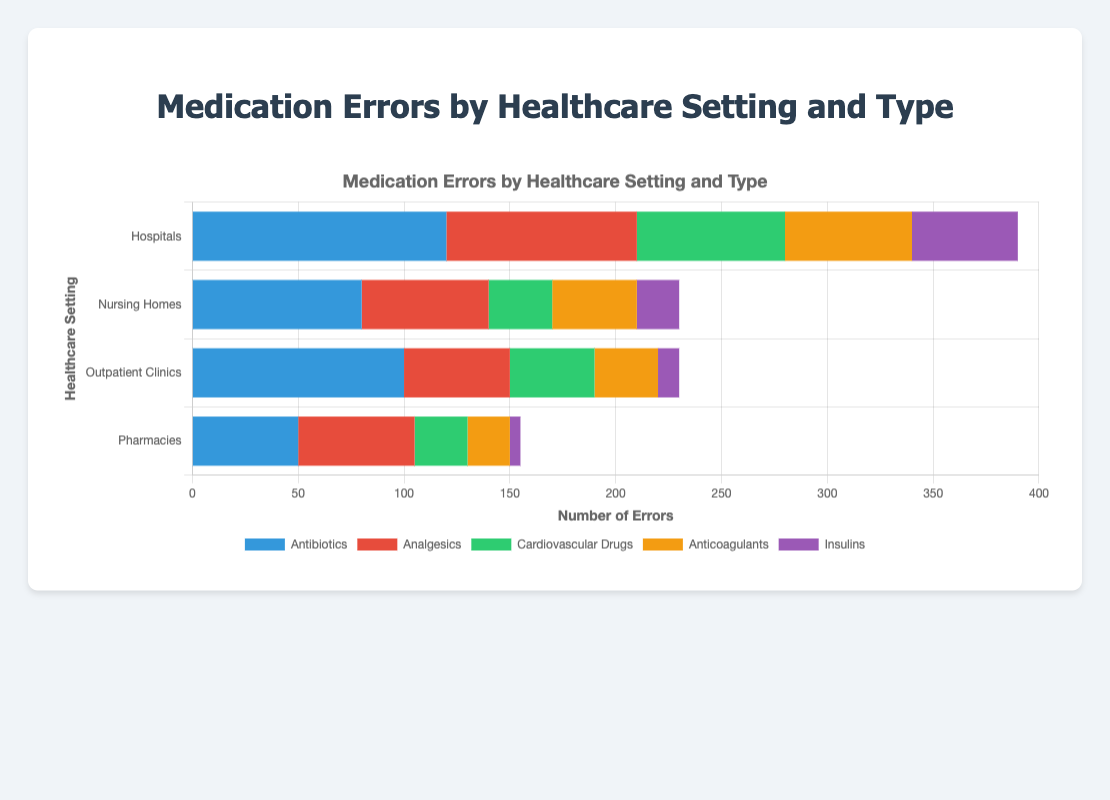Which healthcare setting has the highest number of medication errors in total? To determine the setting with the highest total medication errors, sum the errors for each setting. Hospitals: 120 + 90 + 70 + 60 + 50 = 390, Nursing Homes: 80 + 60 + 30 + 40 + 20 = 230, Outpatient Clinics: 100 + 50 + 40 + 30 + 10 = 230, Pharmacies: 50 + 55 + 25 + 20 + 5 = 155. The hospital has the highest number.
Answer: Hospitals In which healthcare setting are antibiotic errors the most frequent? Look for the longest segment in the bar representing antibiotics across each healthcare setting: Hospitals (120), Nursing Homes (80), Outpatient Clinics (100), Pharmacies (50). The highest value is 120 in Hospitals.
Answer: Hospitals What is the sum of Analgesic errors in Nursing Homes and Pharmacies? Add the number of Analgesic errors in Nursing Homes and Pharmacies. Nursing Homes: 60, Pharmacies: 55. Hence, 60 + 55 = 115.
Answer: 115 Which type of medication has the least errors in Outpatient Clinics? Examine the Outpatient Clinics bar for each medication type: Antibiotics (100), Analgesics (50), Cardiovascular Drugs (40), Anticoagulants (30), Insulins (10). Insulins have the lowest value, 10.
Answer: Insulins How does the number of cardiovascular drug errors in Hospitals compare to those in Nursing Homes? Cardiovascular drug errors in Hospitals are 70, and in Nursing Homes are 30. 70 is greater than 30.
Answer: Greater What is the average number of antibiotic errors across all healthcare settings? Add the number of antibiotic errors across all settings and divide by the number of settings (4). (120 + 80 + 100 + 50) / 4 = 350 / 4 = 87.5.
Answer: 87.5 